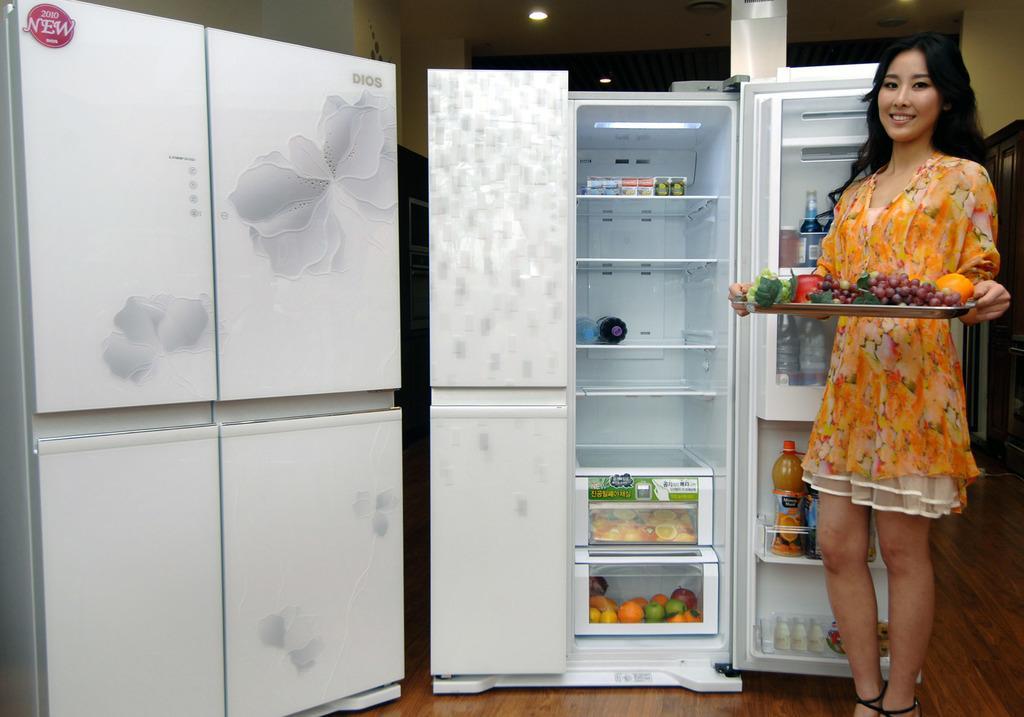How would you summarize this image in a sentence or two? In this image there are two refrigerators on the floor. Right side a woman is standing on the floor. She is holding a tray which is having grapes, orange and apple on it. Behind her there is a door to the wall. Few lights are attached to the roof. In the refrigerator there are few bottles in the racks. In the boxes there are few fruits in it. 